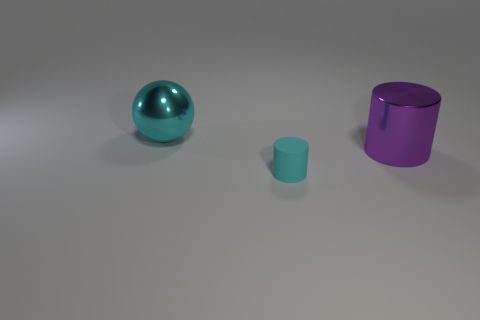What is the shape of the metallic thing that is the same color as the tiny rubber thing?
Your answer should be very brief. Sphere. What number of other objects are the same shape as the big cyan shiny object?
Make the answer very short. 0. What number of metallic things are either cyan cylinders or big gray balls?
Make the answer very short. 0. There is a cyan object that is to the right of the cyan thing that is behind the large purple cylinder; what is its material?
Keep it short and to the point. Rubber. Are there more cyan spheres that are on the right side of the big cyan shiny ball than small cyan rubber things?
Keep it short and to the point. No. Is there a large purple object that has the same material as the cyan cylinder?
Your answer should be compact. No. Does the large object in front of the large sphere have the same shape as the small thing?
Your answer should be very brief. Yes. There is a cyan thing behind the cyan cylinder that is on the right side of the big cyan metallic object; how many cyan objects are to the right of it?
Your response must be concise. 1. Is the number of shiny balls in front of the purple metal cylinder less than the number of tiny cyan rubber cylinders in front of the big cyan metal thing?
Your answer should be compact. Yes. There is another large thing that is the same shape as the rubber thing; what color is it?
Ensure brevity in your answer.  Purple. 